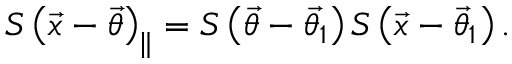<formula> <loc_0><loc_0><loc_500><loc_500>S \left ( \vec { x } - \vec { \theta } \right ) _ { \| } = S \left ( \vec { \theta } - \vec { \theta _ { 1 } } \right ) S \left ( \vec { x } - \vec { \theta } _ { 1 } \right ) .</formula> 